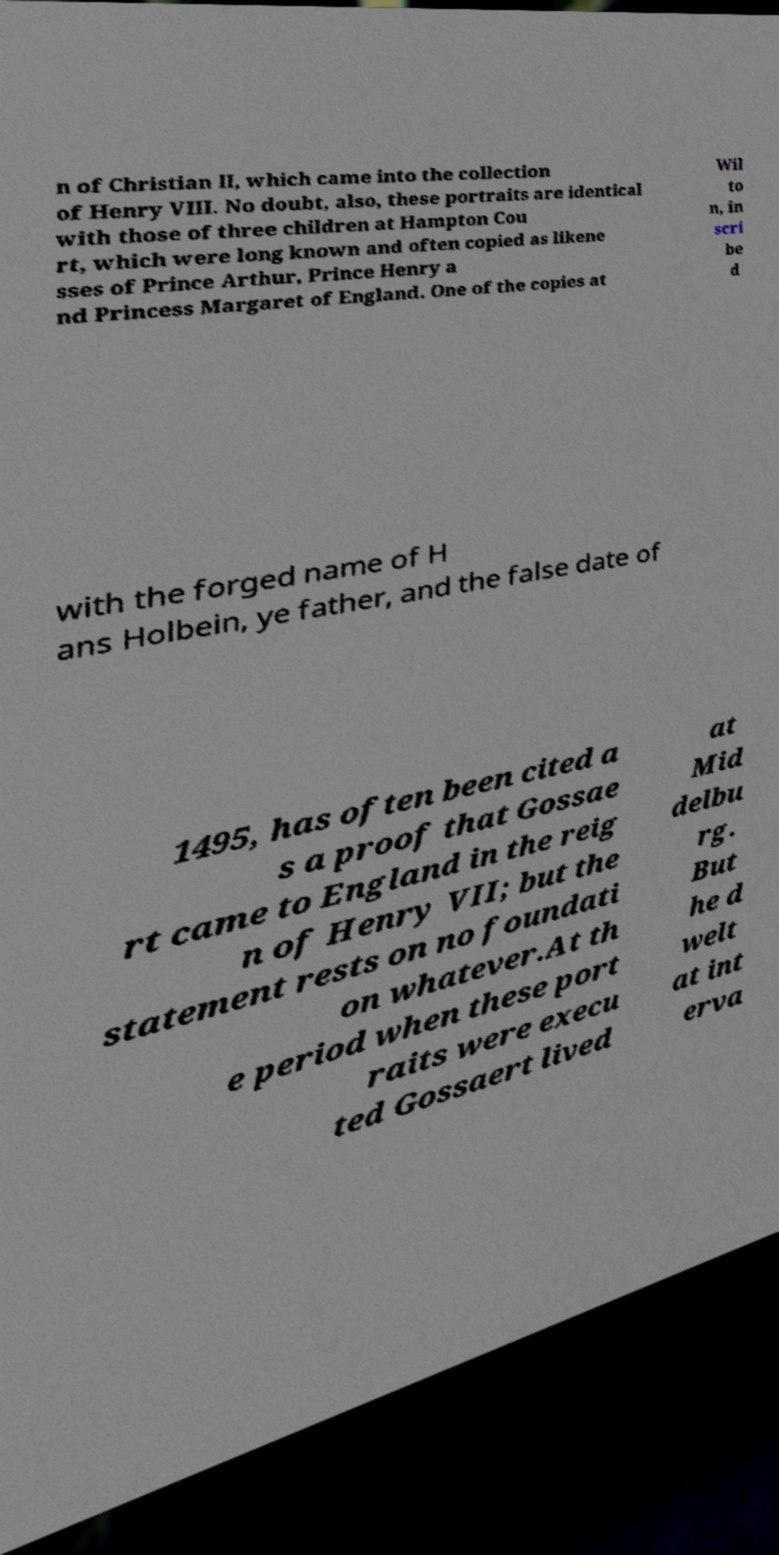Could you extract and type out the text from this image? n of Christian II, which came into the collection of Henry VIII. No doubt, also, these portraits are identical with those of three children at Hampton Cou rt, which were long known and often copied as likene sses of Prince Arthur, Prince Henry a nd Princess Margaret of England. One of the copies at Wil to n, in scri be d with the forged name of H ans Holbein, ye father, and the false date of 1495, has often been cited a s a proof that Gossae rt came to England in the reig n of Henry VII; but the statement rests on no foundati on whatever.At th e period when these port raits were execu ted Gossaert lived at Mid delbu rg. But he d welt at int erva 